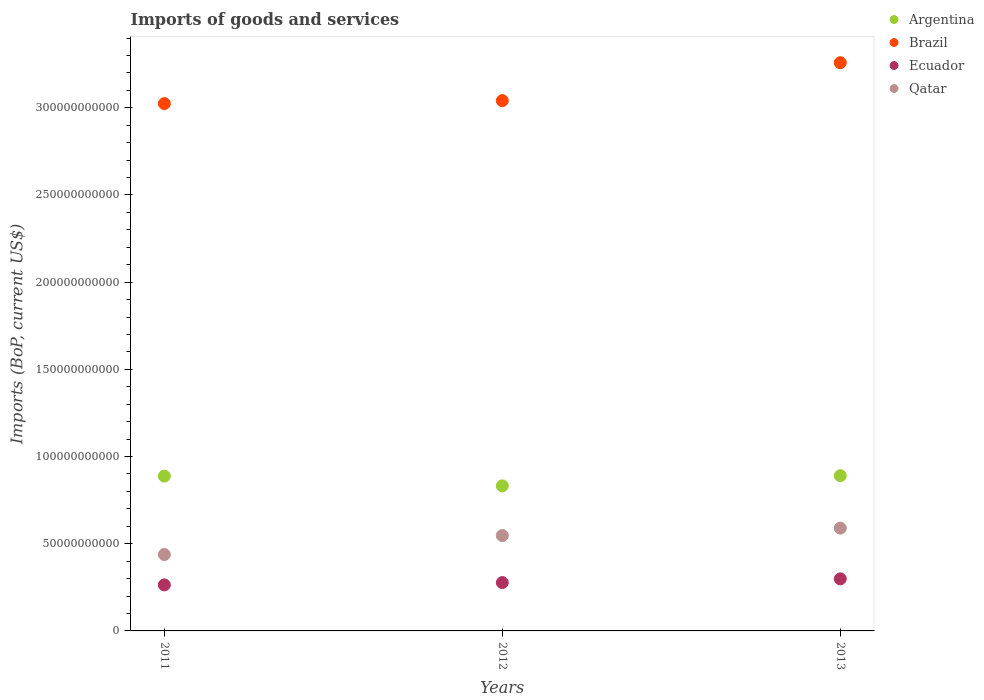How many different coloured dotlines are there?
Provide a short and direct response. 4. Is the number of dotlines equal to the number of legend labels?
Provide a short and direct response. Yes. What is the amount spent on imports in Brazil in 2013?
Your answer should be compact. 3.26e+11. Across all years, what is the maximum amount spent on imports in Brazil?
Make the answer very short. 3.26e+11. Across all years, what is the minimum amount spent on imports in Argentina?
Give a very brief answer. 8.32e+1. What is the total amount spent on imports in Qatar in the graph?
Offer a very short reply. 1.57e+11. What is the difference between the amount spent on imports in Brazil in 2011 and that in 2013?
Make the answer very short. -2.35e+1. What is the difference between the amount spent on imports in Brazil in 2011 and the amount spent on imports in Argentina in 2012?
Make the answer very short. 2.19e+11. What is the average amount spent on imports in Ecuador per year?
Keep it short and to the point. 2.80e+1. In the year 2011, what is the difference between the amount spent on imports in Brazil and amount spent on imports in Qatar?
Give a very brief answer. 2.59e+11. In how many years, is the amount spent on imports in Ecuador greater than 190000000000 US$?
Ensure brevity in your answer.  0. What is the ratio of the amount spent on imports in Qatar in 2011 to that in 2012?
Give a very brief answer. 0.8. Is the difference between the amount spent on imports in Brazil in 2011 and 2013 greater than the difference between the amount spent on imports in Qatar in 2011 and 2013?
Your response must be concise. No. What is the difference between the highest and the second highest amount spent on imports in Qatar?
Offer a very short reply. 4.26e+09. What is the difference between the highest and the lowest amount spent on imports in Ecuador?
Offer a very short reply. 3.47e+09. In how many years, is the amount spent on imports in Argentina greater than the average amount spent on imports in Argentina taken over all years?
Ensure brevity in your answer.  2. Is the amount spent on imports in Ecuador strictly greater than the amount spent on imports in Argentina over the years?
Your response must be concise. No. How many dotlines are there?
Make the answer very short. 4. How many years are there in the graph?
Keep it short and to the point. 3. Does the graph contain any zero values?
Provide a succinct answer. No. How many legend labels are there?
Make the answer very short. 4. What is the title of the graph?
Offer a very short reply. Imports of goods and services. What is the label or title of the Y-axis?
Give a very brief answer. Imports (BoP, current US$). What is the Imports (BoP, current US$) in Argentina in 2011?
Keep it short and to the point. 8.88e+1. What is the Imports (BoP, current US$) of Brazil in 2011?
Your answer should be very brief. 3.02e+11. What is the Imports (BoP, current US$) of Ecuador in 2011?
Offer a very short reply. 2.64e+1. What is the Imports (BoP, current US$) in Qatar in 2011?
Your answer should be compact. 4.38e+1. What is the Imports (BoP, current US$) of Argentina in 2012?
Offer a very short reply. 8.32e+1. What is the Imports (BoP, current US$) in Brazil in 2012?
Provide a short and direct response. 3.04e+11. What is the Imports (BoP, current US$) of Ecuador in 2012?
Provide a succinct answer. 2.77e+1. What is the Imports (BoP, current US$) in Qatar in 2012?
Offer a very short reply. 5.47e+1. What is the Imports (BoP, current US$) in Argentina in 2013?
Your answer should be very brief. 8.90e+1. What is the Imports (BoP, current US$) in Brazil in 2013?
Your answer should be compact. 3.26e+11. What is the Imports (BoP, current US$) in Ecuador in 2013?
Your answer should be compact. 2.99e+1. What is the Imports (BoP, current US$) of Qatar in 2013?
Provide a short and direct response. 5.90e+1. Across all years, what is the maximum Imports (BoP, current US$) of Argentina?
Provide a short and direct response. 8.90e+1. Across all years, what is the maximum Imports (BoP, current US$) of Brazil?
Make the answer very short. 3.26e+11. Across all years, what is the maximum Imports (BoP, current US$) in Ecuador?
Offer a very short reply. 2.99e+1. Across all years, what is the maximum Imports (BoP, current US$) in Qatar?
Keep it short and to the point. 5.90e+1. Across all years, what is the minimum Imports (BoP, current US$) of Argentina?
Your response must be concise. 8.32e+1. Across all years, what is the minimum Imports (BoP, current US$) of Brazil?
Make the answer very short. 3.02e+11. Across all years, what is the minimum Imports (BoP, current US$) in Ecuador?
Your answer should be compact. 2.64e+1. Across all years, what is the minimum Imports (BoP, current US$) in Qatar?
Make the answer very short. 4.38e+1. What is the total Imports (BoP, current US$) of Argentina in the graph?
Provide a short and direct response. 2.61e+11. What is the total Imports (BoP, current US$) of Brazil in the graph?
Your response must be concise. 9.32e+11. What is the total Imports (BoP, current US$) in Ecuador in the graph?
Offer a terse response. 8.40e+1. What is the total Imports (BoP, current US$) of Qatar in the graph?
Offer a very short reply. 1.57e+11. What is the difference between the Imports (BoP, current US$) in Argentina in 2011 and that in 2012?
Provide a short and direct response. 5.60e+09. What is the difference between the Imports (BoP, current US$) of Brazil in 2011 and that in 2012?
Provide a short and direct response. -1.69e+09. What is the difference between the Imports (BoP, current US$) of Ecuador in 2011 and that in 2012?
Give a very brief answer. -1.32e+09. What is the difference between the Imports (BoP, current US$) in Qatar in 2011 and that in 2012?
Your answer should be compact. -1.09e+1. What is the difference between the Imports (BoP, current US$) in Argentina in 2011 and that in 2013?
Your response must be concise. -2.52e+08. What is the difference between the Imports (BoP, current US$) of Brazil in 2011 and that in 2013?
Keep it short and to the point. -2.35e+1. What is the difference between the Imports (BoP, current US$) in Ecuador in 2011 and that in 2013?
Give a very brief answer. -3.47e+09. What is the difference between the Imports (BoP, current US$) of Qatar in 2011 and that in 2013?
Offer a terse response. -1.52e+1. What is the difference between the Imports (BoP, current US$) in Argentina in 2012 and that in 2013?
Provide a succinct answer. -5.85e+09. What is the difference between the Imports (BoP, current US$) of Brazil in 2012 and that in 2013?
Your response must be concise. -2.18e+1. What is the difference between the Imports (BoP, current US$) of Ecuador in 2012 and that in 2013?
Give a very brief answer. -2.14e+09. What is the difference between the Imports (BoP, current US$) of Qatar in 2012 and that in 2013?
Your answer should be compact. -4.26e+09. What is the difference between the Imports (BoP, current US$) of Argentina in 2011 and the Imports (BoP, current US$) of Brazil in 2012?
Provide a short and direct response. -2.15e+11. What is the difference between the Imports (BoP, current US$) of Argentina in 2011 and the Imports (BoP, current US$) of Ecuador in 2012?
Ensure brevity in your answer.  6.11e+1. What is the difference between the Imports (BoP, current US$) of Argentina in 2011 and the Imports (BoP, current US$) of Qatar in 2012?
Provide a succinct answer. 3.41e+1. What is the difference between the Imports (BoP, current US$) of Brazil in 2011 and the Imports (BoP, current US$) of Ecuador in 2012?
Provide a succinct answer. 2.75e+11. What is the difference between the Imports (BoP, current US$) of Brazil in 2011 and the Imports (BoP, current US$) of Qatar in 2012?
Provide a short and direct response. 2.48e+11. What is the difference between the Imports (BoP, current US$) of Ecuador in 2011 and the Imports (BoP, current US$) of Qatar in 2012?
Your answer should be compact. -2.83e+1. What is the difference between the Imports (BoP, current US$) in Argentina in 2011 and the Imports (BoP, current US$) in Brazil in 2013?
Ensure brevity in your answer.  -2.37e+11. What is the difference between the Imports (BoP, current US$) of Argentina in 2011 and the Imports (BoP, current US$) of Ecuador in 2013?
Ensure brevity in your answer.  5.89e+1. What is the difference between the Imports (BoP, current US$) of Argentina in 2011 and the Imports (BoP, current US$) of Qatar in 2013?
Make the answer very short. 2.98e+1. What is the difference between the Imports (BoP, current US$) in Brazil in 2011 and the Imports (BoP, current US$) in Ecuador in 2013?
Provide a succinct answer. 2.73e+11. What is the difference between the Imports (BoP, current US$) in Brazil in 2011 and the Imports (BoP, current US$) in Qatar in 2013?
Your answer should be very brief. 2.43e+11. What is the difference between the Imports (BoP, current US$) in Ecuador in 2011 and the Imports (BoP, current US$) in Qatar in 2013?
Provide a succinct answer. -3.26e+1. What is the difference between the Imports (BoP, current US$) of Argentina in 2012 and the Imports (BoP, current US$) of Brazil in 2013?
Offer a very short reply. -2.43e+11. What is the difference between the Imports (BoP, current US$) in Argentina in 2012 and the Imports (BoP, current US$) in Ecuador in 2013?
Keep it short and to the point. 5.33e+1. What is the difference between the Imports (BoP, current US$) of Argentina in 2012 and the Imports (BoP, current US$) of Qatar in 2013?
Provide a succinct answer. 2.42e+1. What is the difference between the Imports (BoP, current US$) in Brazil in 2012 and the Imports (BoP, current US$) in Ecuador in 2013?
Ensure brevity in your answer.  2.74e+11. What is the difference between the Imports (BoP, current US$) of Brazil in 2012 and the Imports (BoP, current US$) of Qatar in 2013?
Your response must be concise. 2.45e+11. What is the difference between the Imports (BoP, current US$) in Ecuador in 2012 and the Imports (BoP, current US$) in Qatar in 2013?
Make the answer very short. -3.12e+1. What is the average Imports (BoP, current US$) of Argentina per year?
Keep it short and to the point. 8.70e+1. What is the average Imports (BoP, current US$) of Brazil per year?
Ensure brevity in your answer.  3.11e+11. What is the average Imports (BoP, current US$) in Ecuador per year?
Make the answer very short. 2.80e+1. What is the average Imports (BoP, current US$) of Qatar per year?
Provide a short and direct response. 5.25e+1. In the year 2011, what is the difference between the Imports (BoP, current US$) in Argentina and Imports (BoP, current US$) in Brazil?
Provide a succinct answer. -2.14e+11. In the year 2011, what is the difference between the Imports (BoP, current US$) of Argentina and Imports (BoP, current US$) of Ecuador?
Make the answer very short. 6.24e+1. In the year 2011, what is the difference between the Imports (BoP, current US$) of Argentina and Imports (BoP, current US$) of Qatar?
Offer a terse response. 4.50e+1. In the year 2011, what is the difference between the Imports (BoP, current US$) of Brazil and Imports (BoP, current US$) of Ecuador?
Make the answer very short. 2.76e+11. In the year 2011, what is the difference between the Imports (BoP, current US$) in Brazil and Imports (BoP, current US$) in Qatar?
Ensure brevity in your answer.  2.59e+11. In the year 2011, what is the difference between the Imports (BoP, current US$) in Ecuador and Imports (BoP, current US$) in Qatar?
Offer a very short reply. -1.74e+1. In the year 2012, what is the difference between the Imports (BoP, current US$) of Argentina and Imports (BoP, current US$) of Brazil?
Your answer should be very brief. -2.21e+11. In the year 2012, what is the difference between the Imports (BoP, current US$) in Argentina and Imports (BoP, current US$) in Ecuador?
Give a very brief answer. 5.55e+1. In the year 2012, what is the difference between the Imports (BoP, current US$) in Argentina and Imports (BoP, current US$) in Qatar?
Make the answer very short. 2.85e+1. In the year 2012, what is the difference between the Imports (BoP, current US$) in Brazil and Imports (BoP, current US$) in Ecuador?
Provide a short and direct response. 2.76e+11. In the year 2012, what is the difference between the Imports (BoP, current US$) in Brazil and Imports (BoP, current US$) in Qatar?
Keep it short and to the point. 2.49e+11. In the year 2012, what is the difference between the Imports (BoP, current US$) in Ecuador and Imports (BoP, current US$) in Qatar?
Give a very brief answer. -2.70e+1. In the year 2013, what is the difference between the Imports (BoP, current US$) in Argentina and Imports (BoP, current US$) in Brazil?
Your response must be concise. -2.37e+11. In the year 2013, what is the difference between the Imports (BoP, current US$) in Argentina and Imports (BoP, current US$) in Ecuador?
Your answer should be compact. 5.92e+1. In the year 2013, what is the difference between the Imports (BoP, current US$) of Argentina and Imports (BoP, current US$) of Qatar?
Your answer should be compact. 3.01e+1. In the year 2013, what is the difference between the Imports (BoP, current US$) in Brazil and Imports (BoP, current US$) in Ecuador?
Ensure brevity in your answer.  2.96e+11. In the year 2013, what is the difference between the Imports (BoP, current US$) in Brazil and Imports (BoP, current US$) in Qatar?
Provide a succinct answer. 2.67e+11. In the year 2013, what is the difference between the Imports (BoP, current US$) of Ecuador and Imports (BoP, current US$) of Qatar?
Provide a short and direct response. -2.91e+1. What is the ratio of the Imports (BoP, current US$) in Argentina in 2011 to that in 2012?
Your response must be concise. 1.07. What is the ratio of the Imports (BoP, current US$) in Ecuador in 2011 to that in 2012?
Make the answer very short. 0.95. What is the ratio of the Imports (BoP, current US$) in Qatar in 2011 to that in 2012?
Offer a terse response. 0.8. What is the ratio of the Imports (BoP, current US$) in Argentina in 2011 to that in 2013?
Provide a short and direct response. 1. What is the ratio of the Imports (BoP, current US$) in Brazil in 2011 to that in 2013?
Make the answer very short. 0.93. What is the ratio of the Imports (BoP, current US$) of Ecuador in 2011 to that in 2013?
Offer a terse response. 0.88. What is the ratio of the Imports (BoP, current US$) of Qatar in 2011 to that in 2013?
Give a very brief answer. 0.74. What is the ratio of the Imports (BoP, current US$) in Argentina in 2012 to that in 2013?
Your answer should be compact. 0.93. What is the ratio of the Imports (BoP, current US$) of Brazil in 2012 to that in 2013?
Offer a very short reply. 0.93. What is the ratio of the Imports (BoP, current US$) of Ecuador in 2012 to that in 2013?
Provide a short and direct response. 0.93. What is the ratio of the Imports (BoP, current US$) of Qatar in 2012 to that in 2013?
Provide a short and direct response. 0.93. What is the difference between the highest and the second highest Imports (BoP, current US$) in Argentina?
Your response must be concise. 2.52e+08. What is the difference between the highest and the second highest Imports (BoP, current US$) of Brazil?
Keep it short and to the point. 2.18e+1. What is the difference between the highest and the second highest Imports (BoP, current US$) of Ecuador?
Offer a terse response. 2.14e+09. What is the difference between the highest and the second highest Imports (BoP, current US$) in Qatar?
Your answer should be very brief. 4.26e+09. What is the difference between the highest and the lowest Imports (BoP, current US$) in Argentina?
Offer a very short reply. 5.85e+09. What is the difference between the highest and the lowest Imports (BoP, current US$) of Brazil?
Your response must be concise. 2.35e+1. What is the difference between the highest and the lowest Imports (BoP, current US$) of Ecuador?
Give a very brief answer. 3.47e+09. What is the difference between the highest and the lowest Imports (BoP, current US$) of Qatar?
Your answer should be compact. 1.52e+1. 